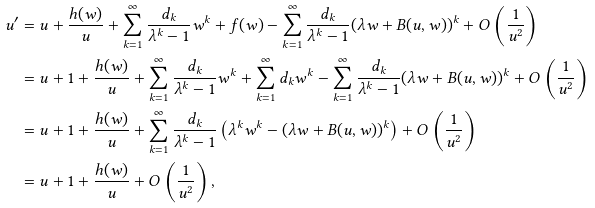<formula> <loc_0><loc_0><loc_500><loc_500>u ^ { \prime } & = u + \frac { h ( w ) } { u } + \sum _ { k = 1 } ^ { \infty } \frac { d _ { k } } { \lambda ^ { k } - 1 } w ^ { k } + f ( w ) - \sum _ { k = 1 } ^ { \infty } \frac { d _ { k } } { \lambda ^ { k } - 1 } ( \lambda w + B ( u , w ) ) ^ { k } + O \left ( \frac { 1 } { u ^ { 2 } } \right ) \\ & = u + 1 + \frac { h ( w ) } { u } + \sum _ { k = 1 } ^ { \infty } \frac { d _ { k } } { \lambda ^ { k } - 1 } w ^ { k } + \sum _ { k = 1 } ^ { \infty } d _ { k } w ^ { k } - \sum _ { k = 1 } ^ { \infty } \frac { d _ { k } } { \lambda ^ { k } - 1 } ( \lambda w + B ( u , w ) ) ^ { k } + O \left ( \frac { 1 } { u ^ { 2 } } \right ) \\ & = u + 1 + \frac { h ( w ) } { u } + \sum _ { k = 1 } ^ { \infty } \frac { d _ { k } } { \lambda ^ { k } - 1 } \left ( \lambda ^ { k } w ^ { k } - ( \lambda w + B ( u , w ) ) ^ { k } \right ) + O \left ( \frac { 1 } { u ^ { 2 } } \right ) \\ & = u + 1 + \frac { h ( w ) } { u } + O \left ( \frac { 1 } { u ^ { 2 } } \right ) ,</formula> 